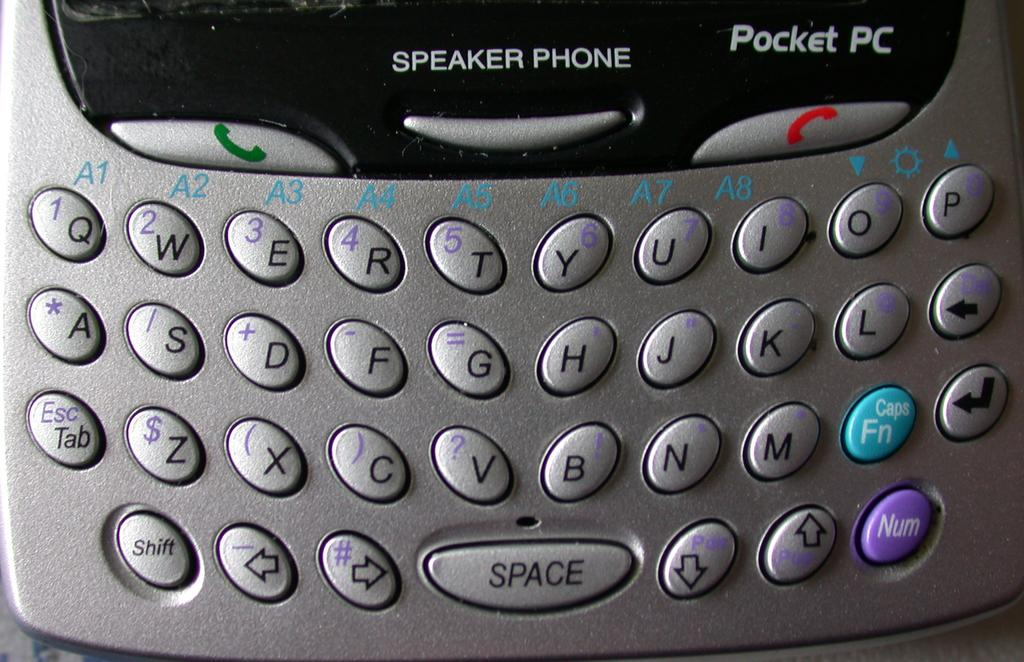<image>
Summarize the visual content of the image. pocket pc speaker phone in silver it looks like an old phone 